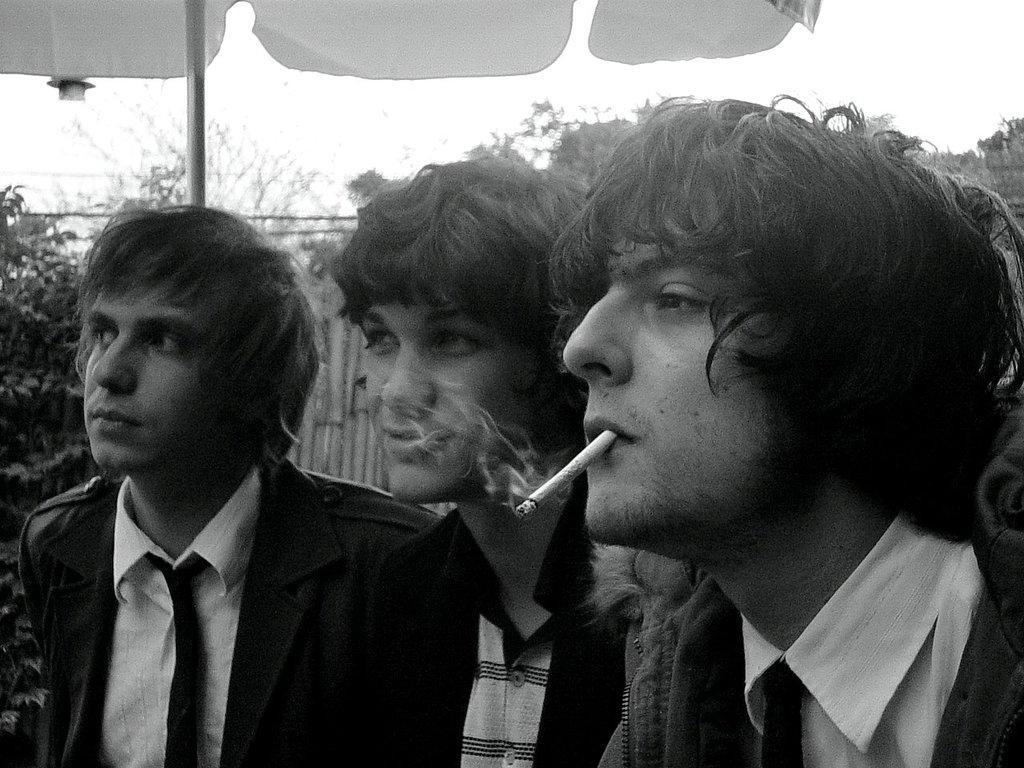How would you summarize this image in a sentence or two? In the foreground of this black and white image, there are three men and a man with cigarette in his mouth. In the background, there are trees and it seems like an umbrella at the top. 